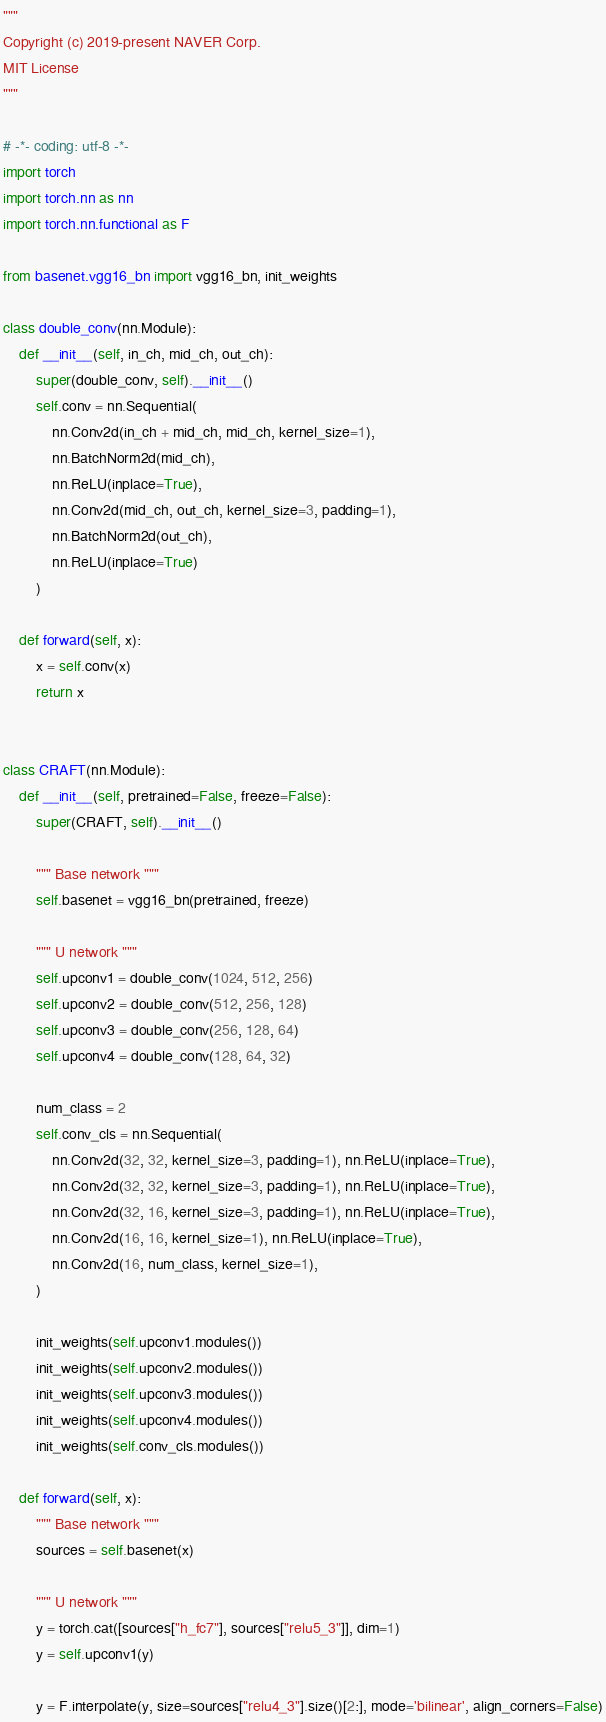<code> <loc_0><loc_0><loc_500><loc_500><_Python_>"""  
Copyright (c) 2019-present NAVER Corp.
MIT License
"""

# -*- coding: utf-8 -*-
import torch
import torch.nn as nn
import torch.nn.functional as F

from basenet.vgg16_bn import vgg16_bn, init_weights

class double_conv(nn.Module):
    def __init__(self, in_ch, mid_ch, out_ch):
        super(double_conv, self).__init__()
        self.conv = nn.Sequential(
            nn.Conv2d(in_ch + mid_ch, mid_ch, kernel_size=1),
            nn.BatchNorm2d(mid_ch),
            nn.ReLU(inplace=True),
            nn.Conv2d(mid_ch, out_ch, kernel_size=3, padding=1),
            nn.BatchNorm2d(out_ch),
            nn.ReLU(inplace=True)
        )

    def forward(self, x):
        x = self.conv(x)
        return x


class CRAFT(nn.Module):
    def __init__(self, pretrained=False, freeze=False):
        super(CRAFT, self).__init__()

        """ Base network """
        self.basenet = vgg16_bn(pretrained, freeze)

        """ U network """
        self.upconv1 = double_conv(1024, 512, 256)
        self.upconv2 = double_conv(512, 256, 128)
        self.upconv3 = double_conv(256, 128, 64)
        self.upconv4 = double_conv(128, 64, 32)

        num_class = 2
        self.conv_cls = nn.Sequential(
            nn.Conv2d(32, 32, kernel_size=3, padding=1), nn.ReLU(inplace=True),
            nn.Conv2d(32, 32, kernel_size=3, padding=1), nn.ReLU(inplace=True),
            nn.Conv2d(32, 16, kernel_size=3, padding=1), nn.ReLU(inplace=True),
            nn.Conv2d(16, 16, kernel_size=1), nn.ReLU(inplace=True),
            nn.Conv2d(16, num_class, kernel_size=1),
        )

        init_weights(self.upconv1.modules())
        init_weights(self.upconv2.modules())
        init_weights(self.upconv3.modules())
        init_weights(self.upconv4.modules())
        init_weights(self.conv_cls.modules())
        
    def forward(self, x):
        """ Base network """
        sources = self.basenet(x)

        """ U network """
        y = torch.cat([sources["h_fc7"], sources["relu5_3"]], dim=1)
        y = self.upconv1(y)

        y = F.interpolate(y, size=sources["relu4_3"].size()[2:], mode='bilinear', align_corners=False)</code> 